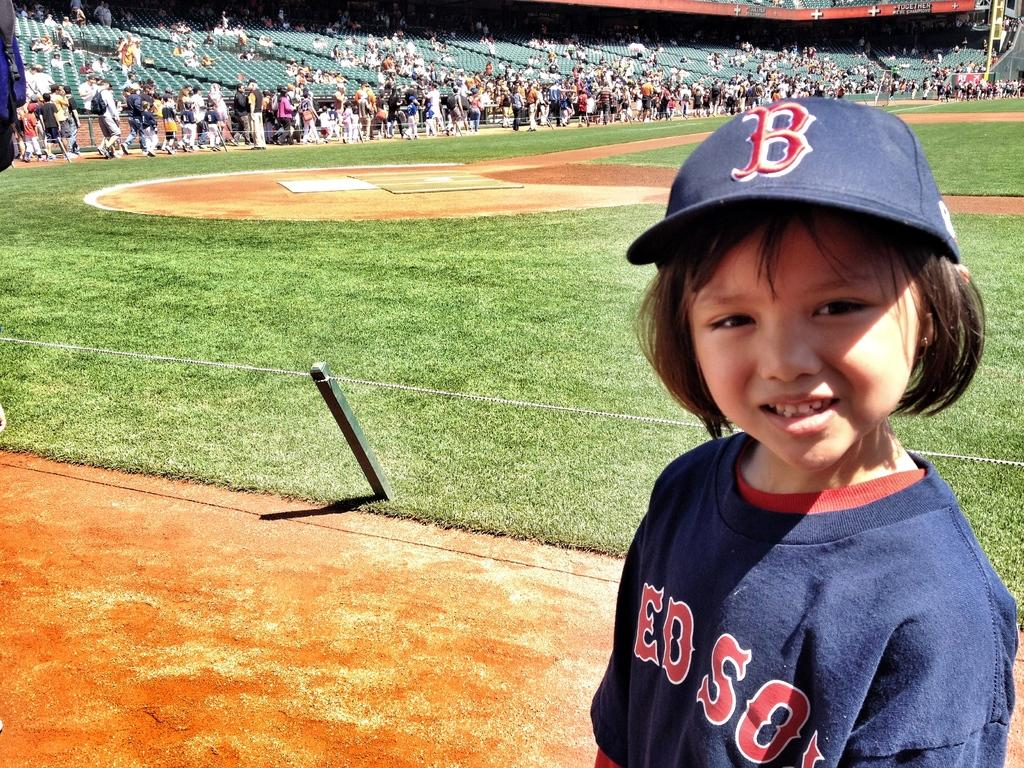<image>
Render a clear and concise summary of the photo. A young spectator is at a baseball field wearing a blue hat with a B on it. 